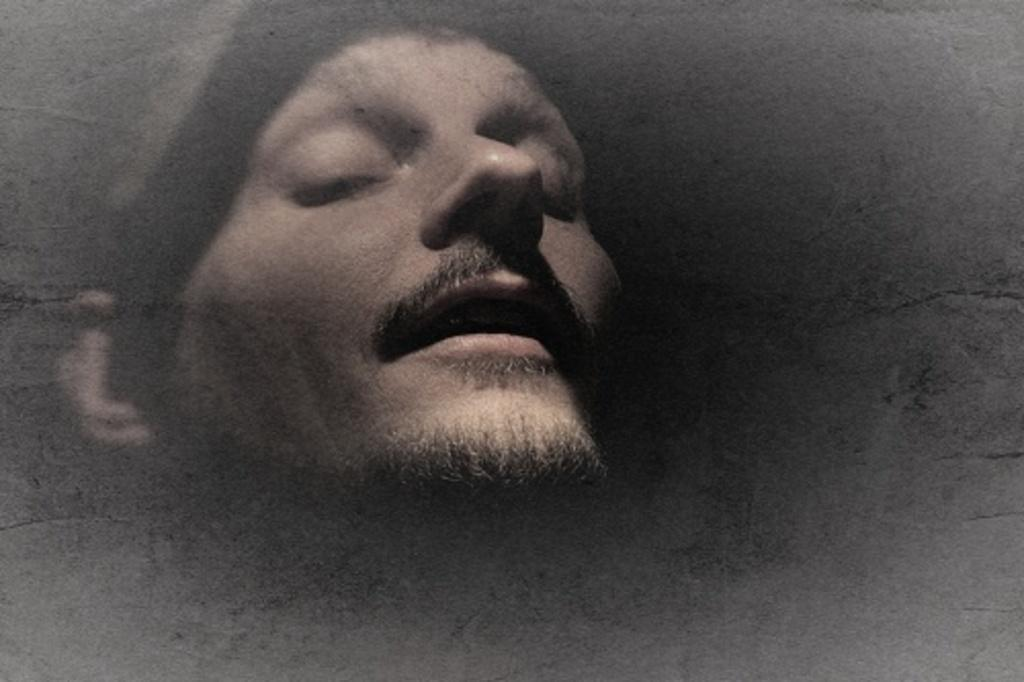What is the main subject of the image? The main subject of the image is a man's face. What is the man's mouth doing in the image? The man's mouth is open in the image. What type of cakes are being served on the flight in the image? There is no flight or cakes present in the image; it only features a man's face with his mouth open. 